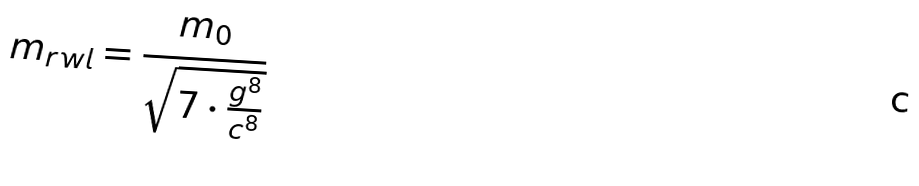Convert formula to latex. <formula><loc_0><loc_0><loc_500><loc_500>m _ { r w l } = \frac { m _ { 0 } } { \sqrt { 7 \cdot \frac { g ^ { 8 } } { c ^ { 8 } } } }</formula> 